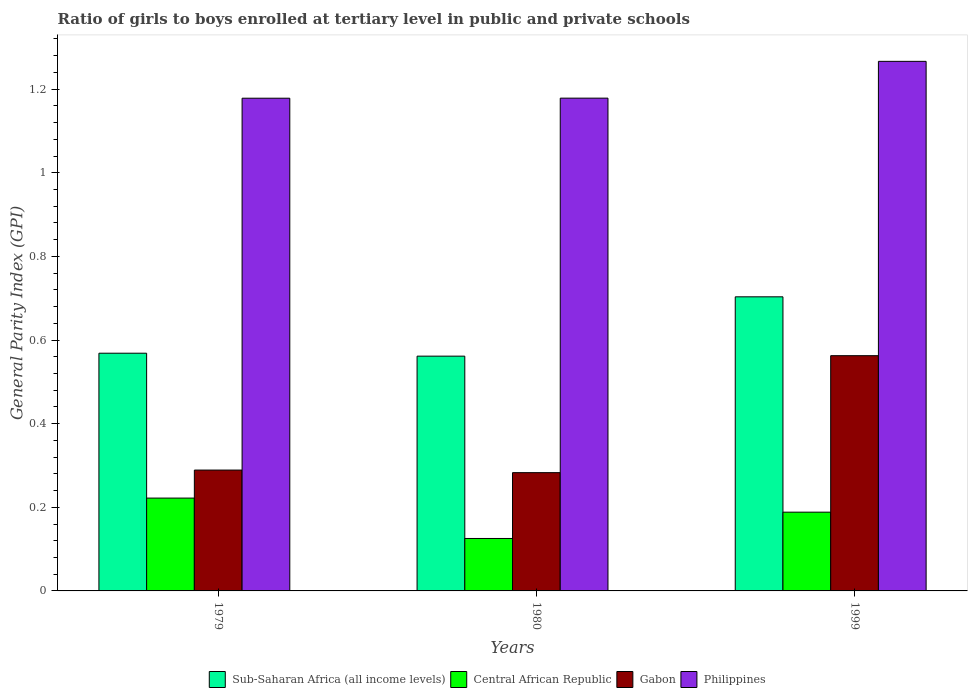How many different coloured bars are there?
Ensure brevity in your answer.  4. Are the number of bars per tick equal to the number of legend labels?
Your answer should be very brief. Yes. How many bars are there on the 1st tick from the right?
Give a very brief answer. 4. In how many cases, is the number of bars for a given year not equal to the number of legend labels?
Give a very brief answer. 0. What is the general parity index in Philippines in 1979?
Provide a succinct answer. 1.18. Across all years, what is the maximum general parity index in Sub-Saharan Africa (all income levels)?
Keep it short and to the point. 0.7. Across all years, what is the minimum general parity index in Gabon?
Your answer should be very brief. 0.28. In which year was the general parity index in Philippines maximum?
Provide a succinct answer. 1999. In which year was the general parity index in Sub-Saharan Africa (all income levels) minimum?
Keep it short and to the point. 1980. What is the total general parity index in Gabon in the graph?
Make the answer very short. 1.13. What is the difference between the general parity index in Gabon in 1979 and that in 1980?
Offer a terse response. 0.01. What is the difference between the general parity index in Gabon in 1999 and the general parity index in Philippines in 1980?
Provide a short and direct response. -0.62. What is the average general parity index in Philippines per year?
Your answer should be compact. 1.21. In the year 1979, what is the difference between the general parity index in Philippines and general parity index in Sub-Saharan Africa (all income levels)?
Offer a terse response. 0.61. What is the ratio of the general parity index in Philippines in 1980 to that in 1999?
Give a very brief answer. 0.93. Is the general parity index in Philippines in 1980 less than that in 1999?
Offer a very short reply. Yes. What is the difference between the highest and the second highest general parity index in Central African Republic?
Your response must be concise. 0.03. What is the difference between the highest and the lowest general parity index in Sub-Saharan Africa (all income levels)?
Keep it short and to the point. 0.14. In how many years, is the general parity index in Central African Republic greater than the average general parity index in Central African Republic taken over all years?
Offer a very short reply. 2. Is the sum of the general parity index in Central African Republic in 1979 and 1999 greater than the maximum general parity index in Philippines across all years?
Ensure brevity in your answer.  No. What does the 1st bar from the left in 1979 represents?
Keep it short and to the point. Sub-Saharan Africa (all income levels). What does the 1st bar from the right in 1980 represents?
Make the answer very short. Philippines. Is it the case that in every year, the sum of the general parity index in Sub-Saharan Africa (all income levels) and general parity index in Gabon is greater than the general parity index in Philippines?
Your response must be concise. No. Are all the bars in the graph horizontal?
Give a very brief answer. No. How many years are there in the graph?
Your answer should be compact. 3. Are the values on the major ticks of Y-axis written in scientific E-notation?
Offer a terse response. No. Does the graph contain any zero values?
Keep it short and to the point. No. Does the graph contain grids?
Your response must be concise. No. Where does the legend appear in the graph?
Offer a terse response. Bottom center. How many legend labels are there?
Give a very brief answer. 4. What is the title of the graph?
Make the answer very short. Ratio of girls to boys enrolled at tertiary level in public and private schools. What is the label or title of the X-axis?
Your response must be concise. Years. What is the label or title of the Y-axis?
Keep it short and to the point. General Parity Index (GPI). What is the General Parity Index (GPI) in Sub-Saharan Africa (all income levels) in 1979?
Your answer should be very brief. 0.57. What is the General Parity Index (GPI) of Central African Republic in 1979?
Make the answer very short. 0.22. What is the General Parity Index (GPI) of Gabon in 1979?
Your answer should be compact. 0.29. What is the General Parity Index (GPI) of Philippines in 1979?
Keep it short and to the point. 1.18. What is the General Parity Index (GPI) of Sub-Saharan Africa (all income levels) in 1980?
Offer a very short reply. 0.56. What is the General Parity Index (GPI) in Central African Republic in 1980?
Offer a very short reply. 0.13. What is the General Parity Index (GPI) in Gabon in 1980?
Your answer should be very brief. 0.28. What is the General Parity Index (GPI) in Philippines in 1980?
Offer a terse response. 1.18. What is the General Parity Index (GPI) of Sub-Saharan Africa (all income levels) in 1999?
Your answer should be compact. 0.7. What is the General Parity Index (GPI) in Central African Republic in 1999?
Provide a succinct answer. 0.19. What is the General Parity Index (GPI) of Gabon in 1999?
Keep it short and to the point. 0.56. What is the General Parity Index (GPI) in Philippines in 1999?
Your response must be concise. 1.27. Across all years, what is the maximum General Parity Index (GPI) in Sub-Saharan Africa (all income levels)?
Your response must be concise. 0.7. Across all years, what is the maximum General Parity Index (GPI) in Central African Republic?
Offer a very short reply. 0.22. Across all years, what is the maximum General Parity Index (GPI) in Gabon?
Give a very brief answer. 0.56. Across all years, what is the maximum General Parity Index (GPI) in Philippines?
Your answer should be very brief. 1.27. Across all years, what is the minimum General Parity Index (GPI) of Sub-Saharan Africa (all income levels)?
Provide a succinct answer. 0.56. Across all years, what is the minimum General Parity Index (GPI) in Central African Republic?
Ensure brevity in your answer.  0.13. Across all years, what is the minimum General Parity Index (GPI) in Gabon?
Your answer should be compact. 0.28. Across all years, what is the minimum General Parity Index (GPI) of Philippines?
Keep it short and to the point. 1.18. What is the total General Parity Index (GPI) of Sub-Saharan Africa (all income levels) in the graph?
Offer a very short reply. 1.83. What is the total General Parity Index (GPI) of Central African Republic in the graph?
Your answer should be compact. 0.54. What is the total General Parity Index (GPI) of Gabon in the graph?
Offer a very short reply. 1.13. What is the total General Parity Index (GPI) of Philippines in the graph?
Make the answer very short. 3.62. What is the difference between the General Parity Index (GPI) of Sub-Saharan Africa (all income levels) in 1979 and that in 1980?
Provide a succinct answer. 0.01. What is the difference between the General Parity Index (GPI) of Central African Republic in 1979 and that in 1980?
Your answer should be compact. 0.1. What is the difference between the General Parity Index (GPI) in Gabon in 1979 and that in 1980?
Ensure brevity in your answer.  0.01. What is the difference between the General Parity Index (GPI) in Philippines in 1979 and that in 1980?
Provide a succinct answer. -0. What is the difference between the General Parity Index (GPI) in Sub-Saharan Africa (all income levels) in 1979 and that in 1999?
Make the answer very short. -0.13. What is the difference between the General Parity Index (GPI) in Central African Republic in 1979 and that in 1999?
Offer a very short reply. 0.03. What is the difference between the General Parity Index (GPI) in Gabon in 1979 and that in 1999?
Offer a very short reply. -0.27. What is the difference between the General Parity Index (GPI) in Philippines in 1979 and that in 1999?
Keep it short and to the point. -0.09. What is the difference between the General Parity Index (GPI) of Sub-Saharan Africa (all income levels) in 1980 and that in 1999?
Keep it short and to the point. -0.14. What is the difference between the General Parity Index (GPI) of Central African Republic in 1980 and that in 1999?
Your answer should be very brief. -0.06. What is the difference between the General Parity Index (GPI) in Gabon in 1980 and that in 1999?
Give a very brief answer. -0.28. What is the difference between the General Parity Index (GPI) of Philippines in 1980 and that in 1999?
Make the answer very short. -0.09. What is the difference between the General Parity Index (GPI) of Sub-Saharan Africa (all income levels) in 1979 and the General Parity Index (GPI) of Central African Republic in 1980?
Make the answer very short. 0.44. What is the difference between the General Parity Index (GPI) of Sub-Saharan Africa (all income levels) in 1979 and the General Parity Index (GPI) of Gabon in 1980?
Give a very brief answer. 0.29. What is the difference between the General Parity Index (GPI) of Sub-Saharan Africa (all income levels) in 1979 and the General Parity Index (GPI) of Philippines in 1980?
Provide a succinct answer. -0.61. What is the difference between the General Parity Index (GPI) in Central African Republic in 1979 and the General Parity Index (GPI) in Gabon in 1980?
Make the answer very short. -0.06. What is the difference between the General Parity Index (GPI) in Central African Republic in 1979 and the General Parity Index (GPI) in Philippines in 1980?
Provide a short and direct response. -0.96. What is the difference between the General Parity Index (GPI) in Gabon in 1979 and the General Parity Index (GPI) in Philippines in 1980?
Your answer should be very brief. -0.89. What is the difference between the General Parity Index (GPI) in Sub-Saharan Africa (all income levels) in 1979 and the General Parity Index (GPI) in Central African Republic in 1999?
Provide a succinct answer. 0.38. What is the difference between the General Parity Index (GPI) of Sub-Saharan Africa (all income levels) in 1979 and the General Parity Index (GPI) of Gabon in 1999?
Your answer should be compact. 0.01. What is the difference between the General Parity Index (GPI) of Sub-Saharan Africa (all income levels) in 1979 and the General Parity Index (GPI) of Philippines in 1999?
Your answer should be compact. -0.7. What is the difference between the General Parity Index (GPI) of Central African Republic in 1979 and the General Parity Index (GPI) of Gabon in 1999?
Give a very brief answer. -0.34. What is the difference between the General Parity Index (GPI) of Central African Republic in 1979 and the General Parity Index (GPI) of Philippines in 1999?
Your answer should be very brief. -1.04. What is the difference between the General Parity Index (GPI) in Gabon in 1979 and the General Parity Index (GPI) in Philippines in 1999?
Give a very brief answer. -0.98. What is the difference between the General Parity Index (GPI) in Sub-Saharan Africa (all income levels) in 1980 and the General Parity Index (GPI) in Central African Republic in 1999?
Give a very brief answer. 0.37. What is the difference between the General Parity Index (GPI) of Sub-Saharan Africa (all income levels) in 1980 and the General Parity Index (GPI) of Gabon in 1999?
Give a very brief answer. -0. What is the difference between the General Parity Index (GPI) of Sub-Saharan Africa (all income levels) in 1980 and the General Parity Index (GPI) of Philippines in 1999?
Offer a very short reply. -0.7. What is the difference between the General Parity Index (GPI) of Central African Republic in 1980 and the General Parity Index (GPI) of Gabon in 1999?
Offer a very short reply. -0.44. What is the difference between the General Parity Index (GPI) of Central African Republic in 1980 and the General Parity Index (GPI) of Philippines in 1999?
Give a very brief answer. -1.14. What is the difference between the General Parity Index (GPI) in Gabon in 1980 and the General Parity Index (GPI) in Philippines in 1999?
Make the answer very short. -0.98. What is the average General Parity Index (GPI) in Sub-Saharan Africa (all income levels) per year?
Offer a terse response. 0.61. What is the average General Parity Index (GPI) in Central African Republic per year?
Your response must be concise. 0.18. What is the average General Parity Index (GPI) of Gabon per year?
Offer a very short reply. 0.38. What is the average General Parity Index (GPI) of Philippines per year?
Make the answer very short. 1.21. In the year 1979, what is the difference between the General Parity Index (GPI) in Sub-Saharan Africa (all income levels) and General Parity Index (GPI) in Central African Republic?
Give a very brief answer. 0.35. In the year 1979, what is the difference between the General Parity Index (GPI) in Sub-Saharan Africa (all income levels) and General Parity Index (GPI) in Gabon?
Ensure brevity in your answer.  0.28. In the year 1979, what is the difference between the General Parity Index (GPI) of Sub-Saharan Africa (all income levels) and General Parity Index (GPI) of Philippines?
Your answer should be compact. -0.61. In the year 1979, what is the difference between the General Parity Index (GPI) of Central African Republic and General Parity Index (GPI) of Gabon?
Offer a very short reply. -0.07. In the year 1979, what is the difference between the General Parity Index (GPI) of Central African Republic and General Parity Index (GPI) of Philippines?
Ensure brevity in your answer.  -0.96. In the year 1979, what is the difference between the General Parity Index (GPI) in Gabon and General Parity Index (GPI) in Philippines?
Your answer should be very brief. -0.89. In the year 1980, what is the difference between the General Parity Index (GPI) in Sub-Saharan Africa (all income levels) and General Parity Index (GPI) in Central African Republic?
Offer a very short reply. 0.44. In the year 1980, what is the difference between the General Parity Index (GPI) of Sub-Saharan Africa (all income levels) and General Parity Index (GPI) of Gabon?
Provide a succinct answer. 0.28. In the year 1980, what is the difference between the General Parity Index (GPI) of Sub-Saharan Africa (all income levels) and General Parity Index (GPI) of Philippines?
Give a very brief answer. -0.62. In the year 1980, what is the difference between the General Parity Index (GPI) in Central African Republic and General Parity Index (GPI) in Gabon?
Give a very brief answer. -0.16. In the year 1980, what is the difference between the General Parity Index (GPI) in Central African Republic and General Parity Index (GPI) in Philippines?
Offer a very short reply. -1.05. In the year 1980, what is the difference between the General Parity Index (GPI) in Gabon and General Parity Index (GPI) in Philippines?
Give a very brief answer. -0.9. In the year 1999, what is the difference between the General Parity Index (GPI) of Sub-Saharan Africa (all income levels) and General Parity Index (GPI) of Central African Republic?
Offer a terse response. 0.51. In the year 1999, what is the difference between the General Parity Index (GPI) of Sub-Saharan Africa (all income levels) and General Parity Index (GPI) of Gabon?
Ensure brevity in your answer.  0.14. In the year 1999, what is the difference between the General Parity Index (GPI) in Sub-Saharan Africa (all income levels) and General Parity Index (GPI) in Philippines?
Your answer should be compact. -0.56. In the year 1999, what is the difference between the General Parity Index (GPI) of Central African Republic and General Parity Index (GPI) of Gabon?
Give a very brief answer. -0.37. In the year 1999, what is the difference between the General Parity Index (GPI) in Central African Republic and General Parity Index (GPI) in Philippines?
Give a very brief answer. -1.08. In the year 1999, what is the difference between the General Parity Index (GPI) of Gabon and General Parity Index (GPI) of Philippines?
Offer a very short reply. -0.7. What is the ratio of the General Parity Index (GPI) of Sub-Saharan Africa (all income levels) in 1979 to that in 1980?
Your answer should be compact. 1.01. What is the ratio of the General Parity Index (GPI) in Central African Republic in 1979 to that in 1980?
Offer a terse response. 1.77. What is the ratio of the General Parity Index (GPI) in Gabon in 1979 to that in 1980?
Provide a short and direct response. 1.02. What is the ratio of the General Parity Index (GPI) of Philippines in 1979 to that in 1980?
Your response must be concise. 1. What is the ratio of the General Parity Index (GPI) in Sub-Saharan Africa (all income levels) in 1979 to that in 1999?
Offer a very short reply. 0.81. What is the ratio of the General Parity Index (GPI) in Central African Republic in 1979 to that in 1999?
Your answer should be compact. 1.18. What is the ratio of the General Parity Index (GPI) of Gabon in 1979 to that in 1999?
Provide a succinct answer. 0.51. What is the ratio of the General Parity Index (GPI) of Philippines in 1979 to that in 1999?
Offer a terse response. 0.93. What is the ratio of the General Parity Index (GPI) in Sub-Saharan Africa (all income levels) in 1980 to that in 1999?
Ensure brevity in your answer.  0.8. What is the ratio of the General Parity Index (GPI) of Central African Republic in 1980 to that in 1999?
Make the answer very short. 0.67. What is the ratio of the General Parity Index (GPI) in Gabon in 1980 to that in 1999?
Keep it short and to the point. 0.5. What is the ratio of the General Parity Index (GPI) of Philippines in 1980 to that in 1999?
Your answer should be very brief. 0.93. What is the difference between the highest and the second highest General Parity Index (GPI) in Sub-Saharan Africa (all income levels)?
Provide a short and direct response. 0.13. What is the difference between the highest and the second highest General Parity Index (GPI) in Central African Republic?
Provide a short and direct response. 0.03. What is the difference between the highest and the second highest General Parity Index (GPI) of Gabon?
Provide a short and direct response. 0.27. What is the difference between the highest and the second highest General Parity Index (GPI) of Philippines?
Offer a terse response. 0.09. What is the difference between the highest and the lowest General Parity Index (GPI) of Sub-Saharan Africa (all income levels)?
Give a very brief answer. 0.14. What is the difference between the highest and the lowest General Parity Index (GPI) of Central African Republic?
Offer a terse response. 0.1. What is the difference between the highest and the lowest General Parity Index (GPI) of Gabon?
Ensure brevity in your answer.  0.28. What is the difference between the highest and the lowest General Parity Index (GPI) in Philippines?
Your answer should be compact. 0.09. 